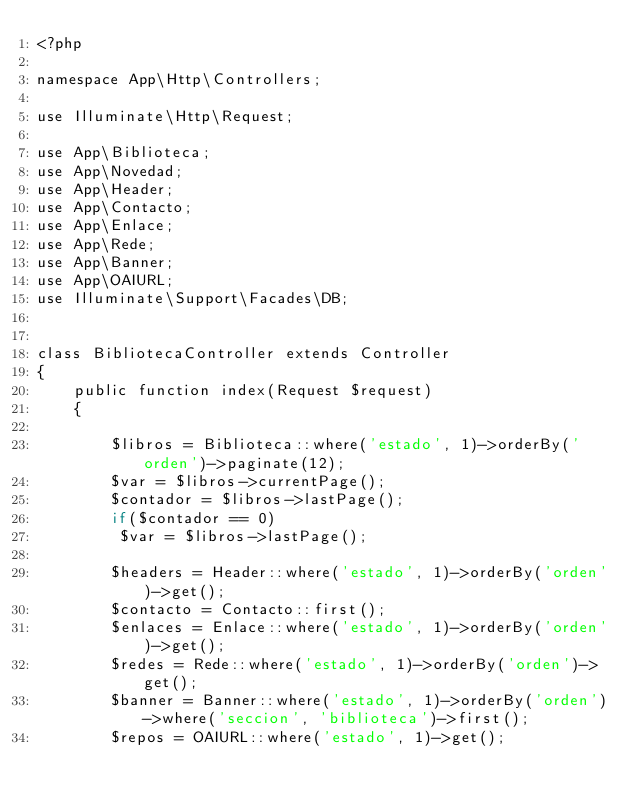<code> <loc_0><loc_0><loc_500><loc_500><_PHP_><?php

namespace App\Http\Controllers;

use Illuminate\Http\Request;

use App\Biblioteca;
use App\Novedad;
use App\Header;
use App\Contacto;
use App\Enlace;
use App\Rede;
use App\Banner;
use App\OAIURL;
use Illuminate\Support\Facades\DB;


class BibliotecaController extends Controller
{
    public function index(Request $request)
    {

        $libros = Biblioteca::where('estado', 1)->orderBy('orden')->paginate(12);
        $var = $libros->currentPage();
        $contador = $libros->lastPage();
        if($contador == 0)
         $var = $libros->lastPage();

        $headers = Header::where('estado', 1)->orderBy('orden')->get();
        $contacto = Contacto::first();
        $enlaces = Enlace::where('estado', 1)->orderBy('orden')->get();
        $redes = Rede::where('estado', 1)->orderBy('orden')->get();
        $banner = Banner::where('estado', 1)->orderBy('orden')->where('seccion', 'biblioteca')->first();
        $repos = OAIURL::where('estado', 1)->get();
</code> 